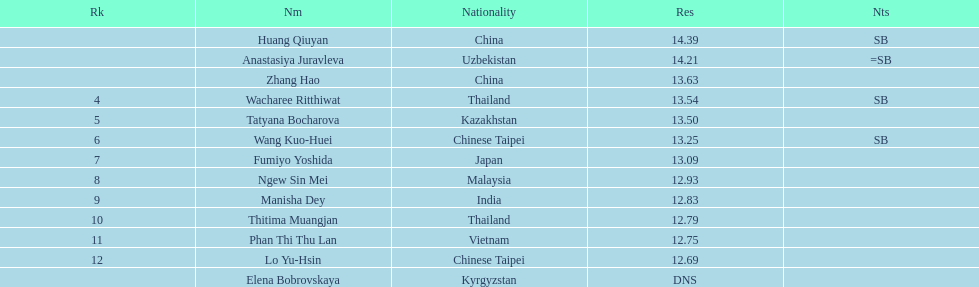What is the difference between huang qiuyan's result and fumiyo yoshida's result? 1.3. Could you help me parse every detail presented in this table? {'header': ['Rk', 'Nm', 'Nationality', 'Res', 'Nts'], 'rows': [['', 'Huang Qiuyan', 'China', '14.39', 'SB'], ['', 'Anastasiya Juravleva', 'Uzbekistan', '14.21', '=SB'], ['', 'Zhang Hao', 'China', '13.63', ''], ['4', 'Wacharee Ritthiwat', 'Thailand', '13.54', 'SB'], ['5', 'Tatyana Bocharova', 'Kazakhstan', '13.50', ''], ['6', 'Wang Kuo-Huei', 'Chinese Taipei', '13.25', 'SB'], ['7', 'Fumiyo Yoshida', 'Japan', '13.09', ''], ['8', 'Ngew Sin Mei', 'Malaysia', '12.93', ''], ['9', 'Manisha Dey', 'India', '12.83', ''], ['10', 'Thitima Muangjan', 'Thailand', '12.79', ''], ['11', 'Phan Thi Thu Lan', 'Vietnam', '12.75', ''], ['12', 'Lo Yu-Hsin', 'Chinese Taipei', '12.69', ''], ['', 'Elena Bobrovskaya', 'Kyrgyzstan', 'DNS', '']]} 